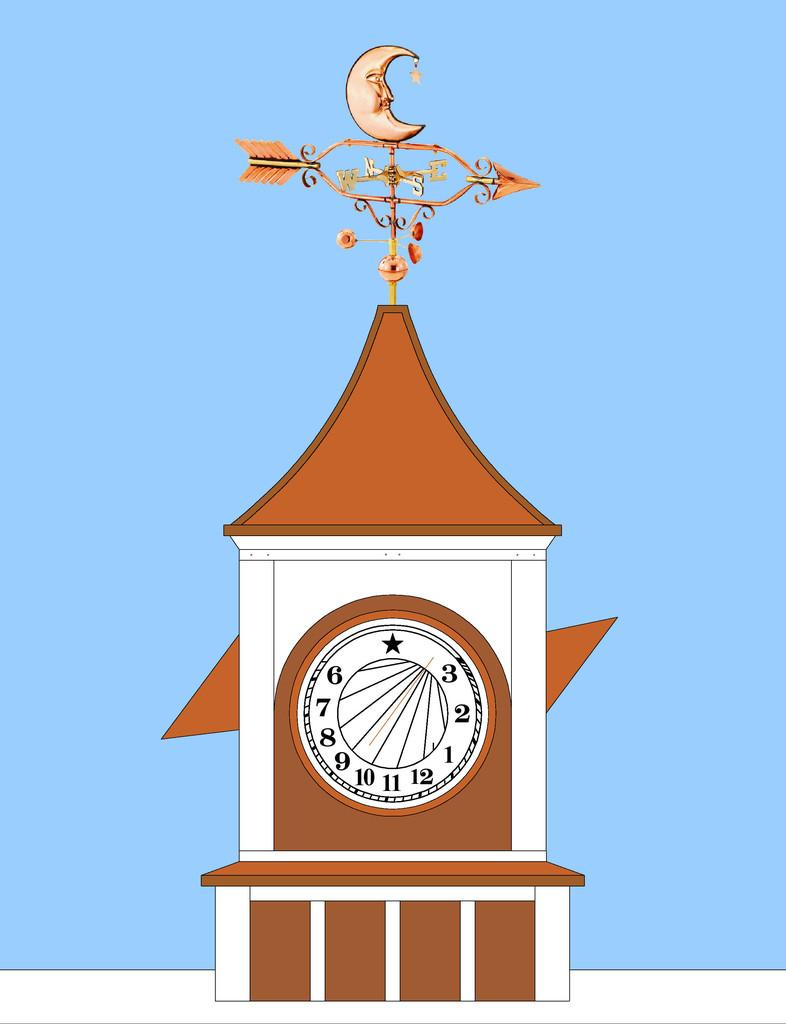<image>
Render a clear and concise summary of the photo. A weather vane is on top of a clock tower that shows the time 1:37. 